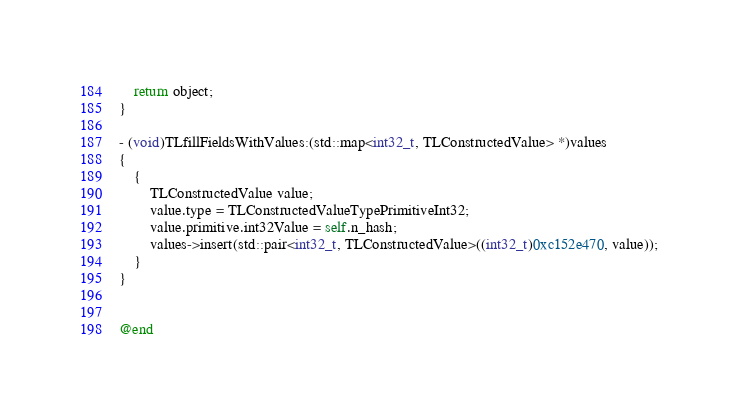<code> <loc_0><loc_0><loc_500><loc_500><_ObjectiveC_>    return object;
}

- (void)TLfillFieldsWithValues:(std::map<int32_t, TLConstructedValue> *)values
{
    {
        TLConstructedValue value;
        value.type = TLConstructedValueTypePrimitiveInt32;
        value.primitive.int32Value = self.n_hash;
        values->insert(std::pair<int32_t, TLConstructedValue>((int32_t)0xc152e470, value));
    }
}


@end

</code> 